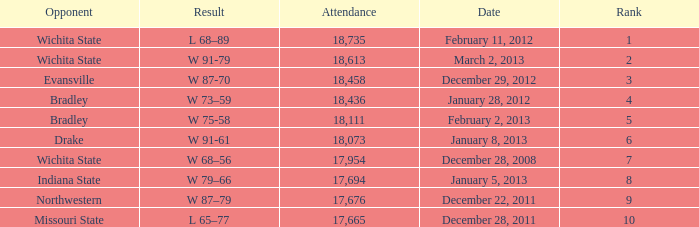What's the rank when attendance was less than 18,073 and having Northwestern as an opponent? 9.0. 